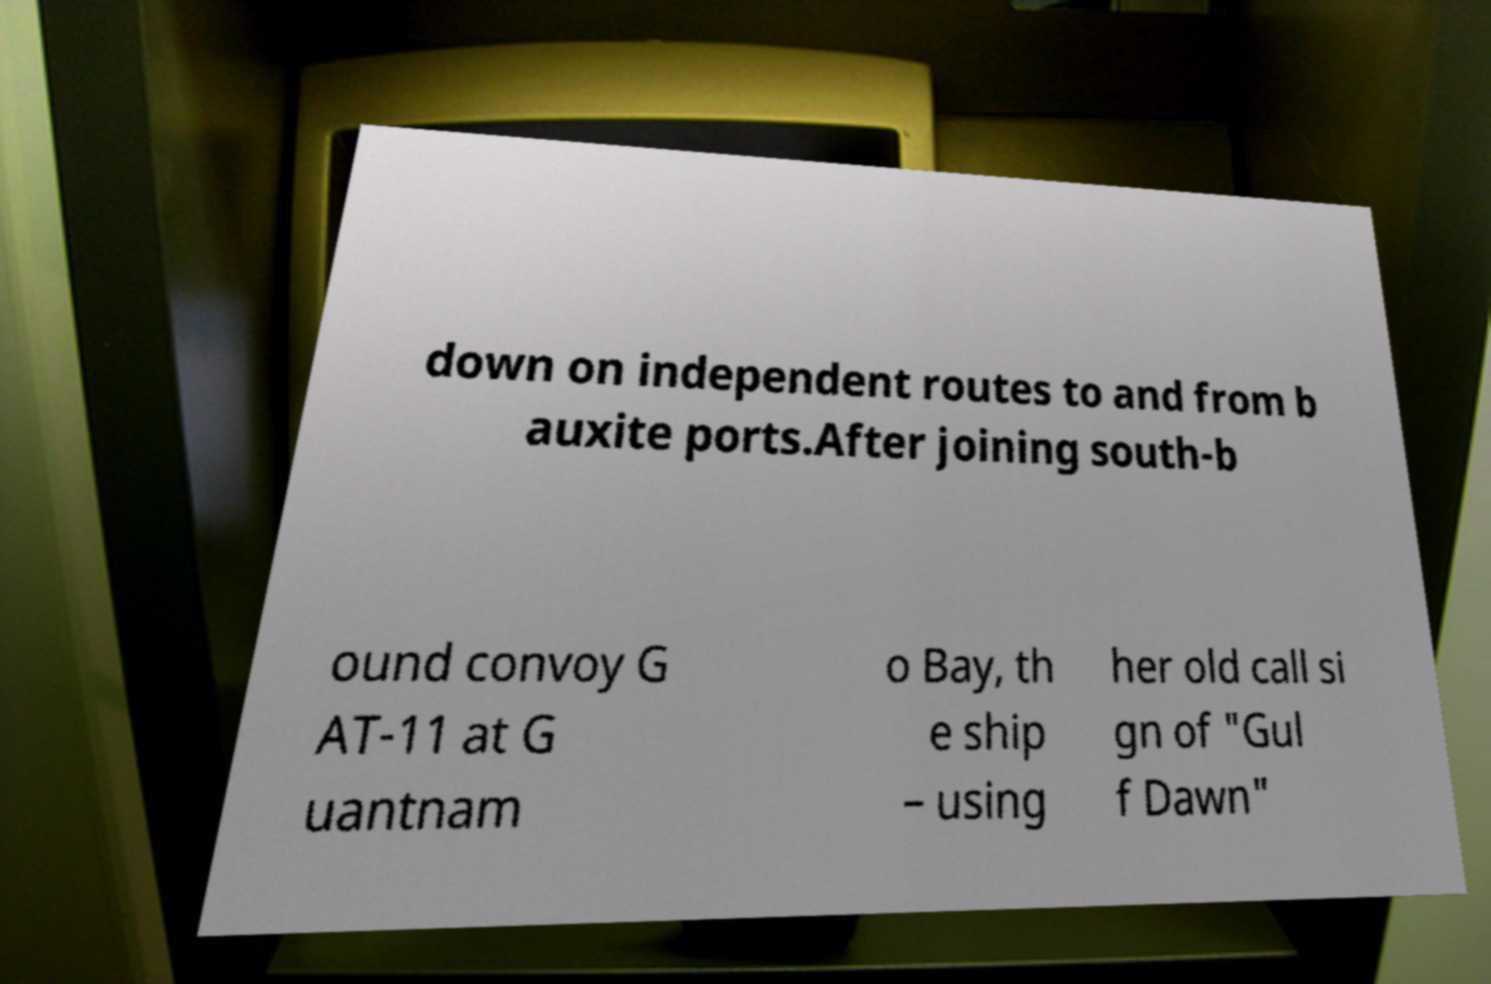What messages or text are displayed in this image? I need them in a readable, typed format. down on independent routes to and from b auxite ports.After joining south-b ound convoy G AT-11 at G uantnam o Bay, th e ship – using her old call si gn of "Gul f Dawn" 